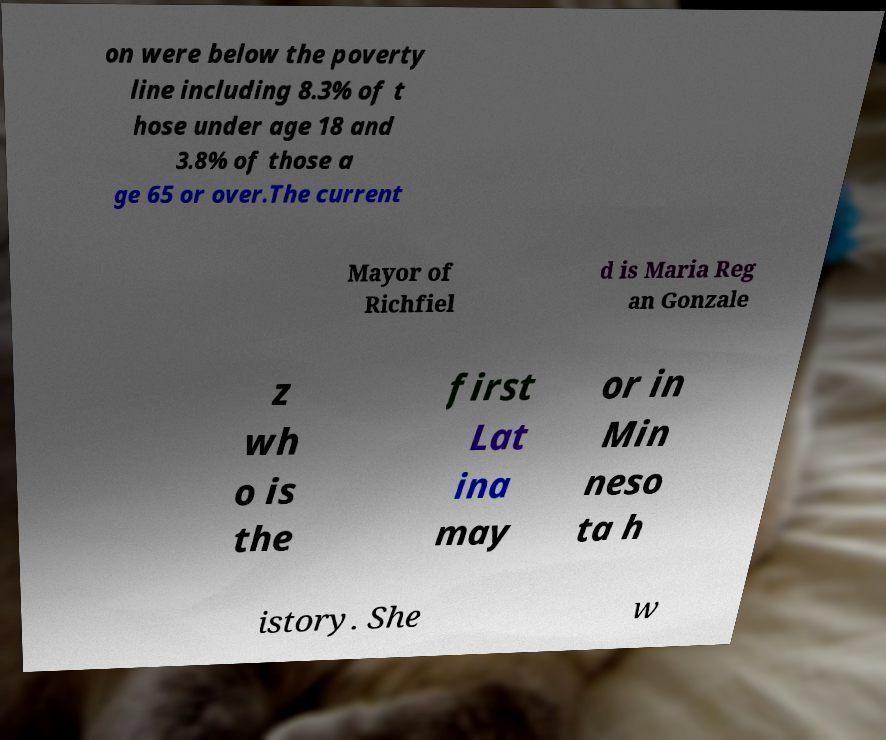Could you extract and type out the text from this image? on were below the poverty line including 8.3% of t hose under age 18 and 3.8% of those a ge 65 or over.The current Mayor of Richfiel d is Maria Reg an Gonzale z wh o is the first Lat ina may or in Min neso ta h istory. She w 